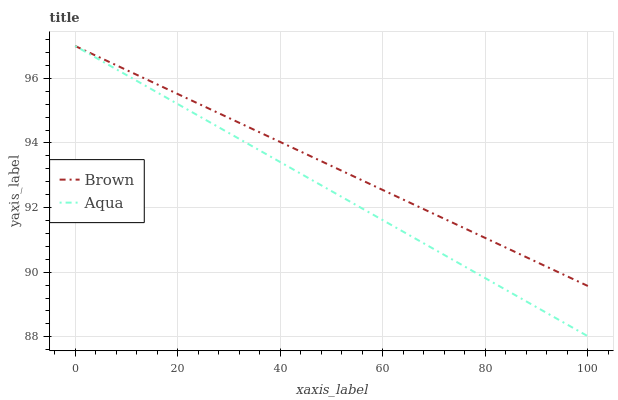Does Aqua have the minimum area under the curve?
Answer yes or no. Yes. Does Brown have the maximum area under the curve?
Answer yes or no. Yes. Does Aqua have the maximum area under the curve?
Answer yes or no. No. Is Brown the smoothest?
Answer yes or no. Yes. Is Aqua the roughest?
Answer yes or no. Yes. Is Aqua the smoothest?
Answer yes or no. No. Does Aqua have the lowest value?
Answer yes or no. Yes. Does Aqua have the highest value?
Answer yes or no. Yes. Does Aqua intersect Brown?
Answer yes or no. Yes. Is Aqua less than Brown?
Answer yes or no. No. Is Aqua greater than Brown?
Answer yes or no. No. 